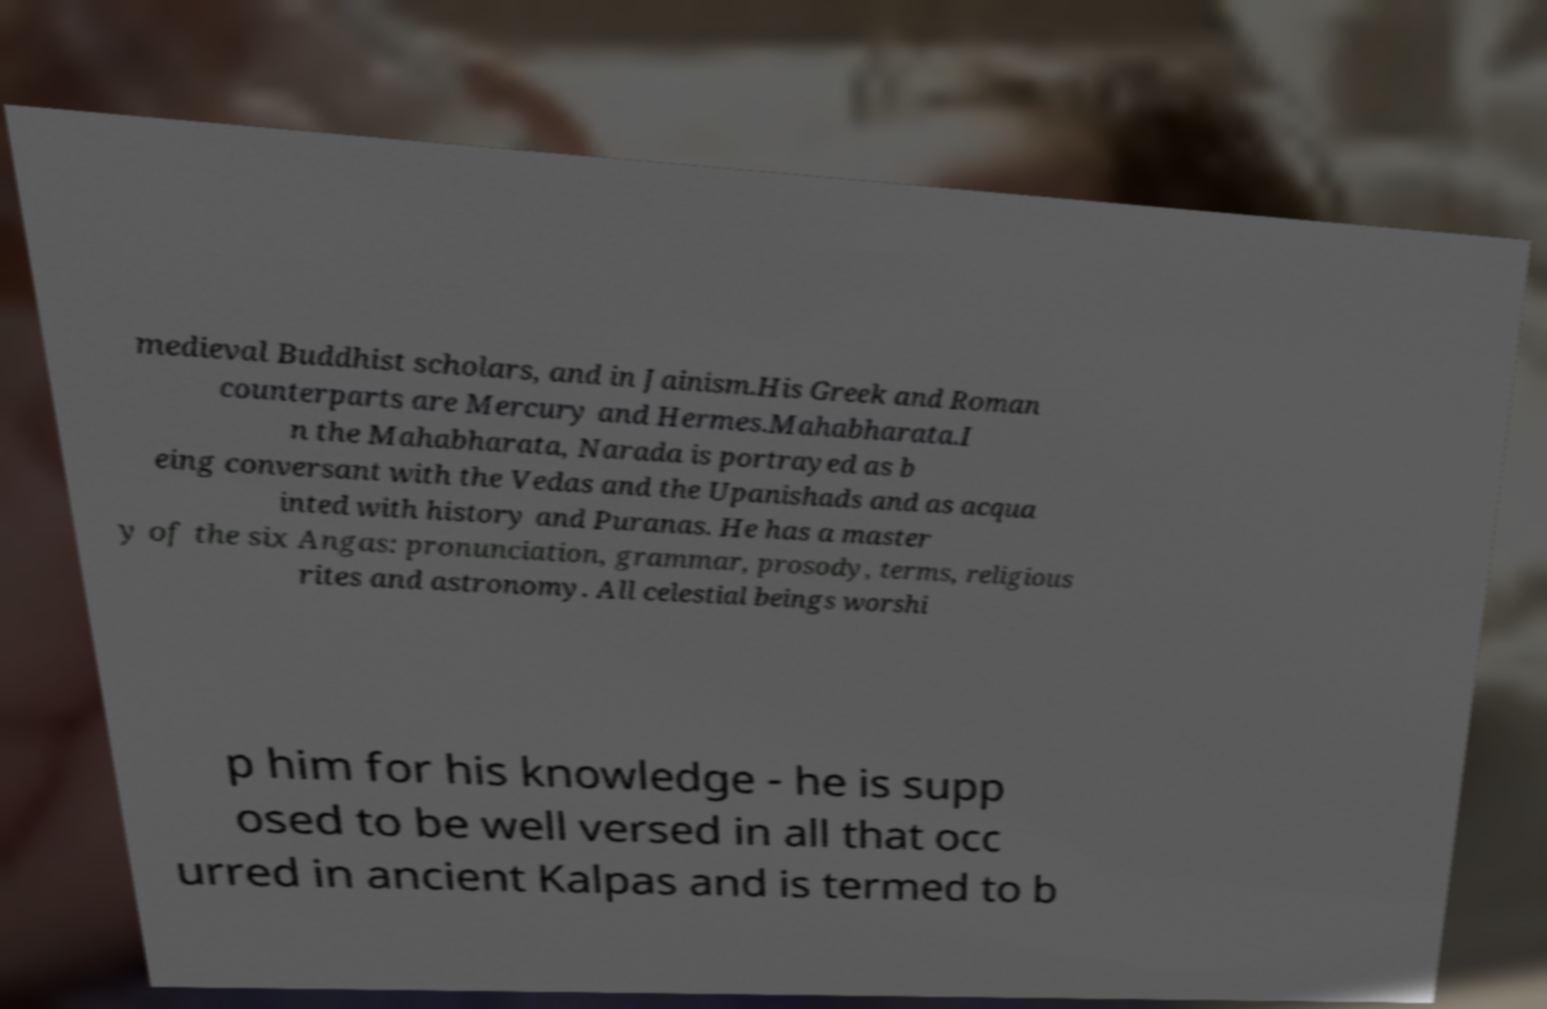For documentation purposes, I need the text within this image transcribed. Could you provide that? medieval Buddhist scholars, and in Jainism.His Greek and Roman counterparts are Mercury and Hermes.Mahabharata.I n the Mahabharata, Narada is portrayed as b eing conversant with the Vedas and the Upanishads and as acqua inted with history and Puranas. He has a master y of the six Angas: pronunciation, grammar, prosody, terms, religious rites and astronomy. All celestial beings worshi p him for his knowledge - he is supp osed to be well versed in all that occ urred in ancient Kalpas and is termed to b 